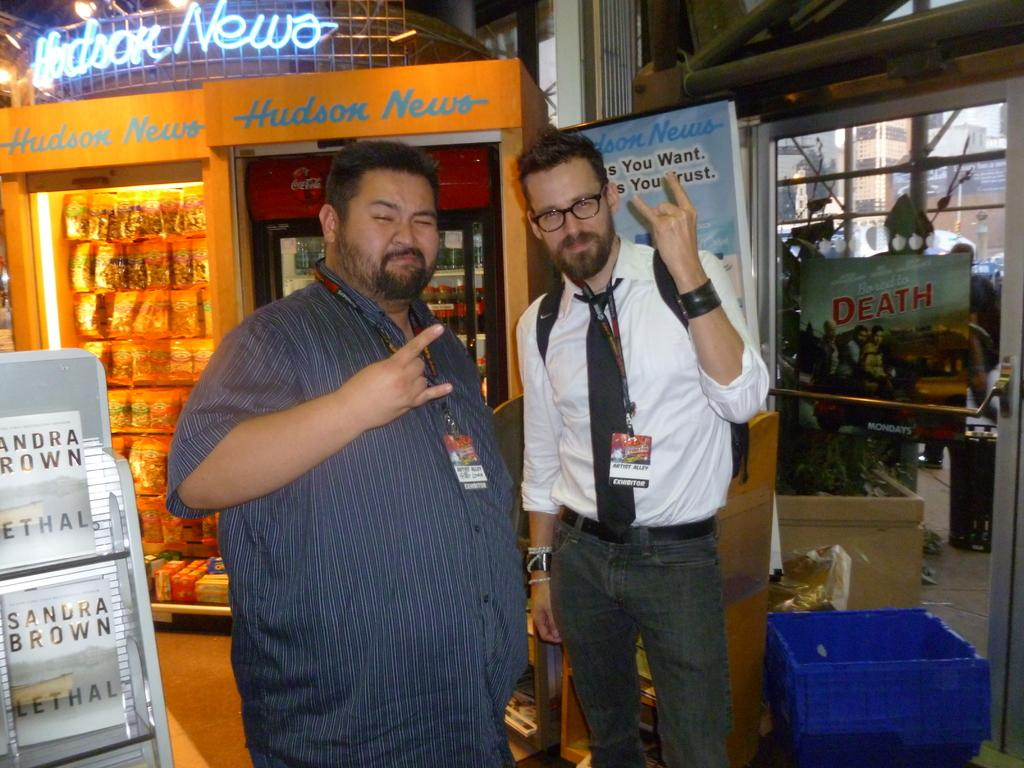How many people are in the image? There are two men in the image. Can you describe the appearance of one of the men? One of the men is wearing spectacles and a tie. What can be seen in the background of the image? There are packets, a tray, and other objects in the background of the image. What is the impulse of the need for the men to place the objects in the image? There is no indication of any impulse or need in the image; it simply shows two men and objects in the background. 